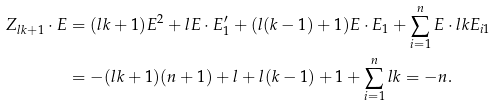<formula> <loc_0><loc_0><loc_500><loc_500>Z _ { l k + 1 } \cdot E & = ( l k + 1 ) E ^ { 2 } + l E \cdot E ^ { \prime } _ { 1 } + ( l ( k - 1 ) + 1 ) E \cdot E _ { 1 } + \sum _ { i = 1 } ^ { n } E \cdot l k E _ { i 1 } \\ & = - ( l k + 1 ) ( n + 1 ) + l + l ( k - 1 ) + 1 + \sum _ { i = 1 } ^ { n } l k = - n .</formula> 